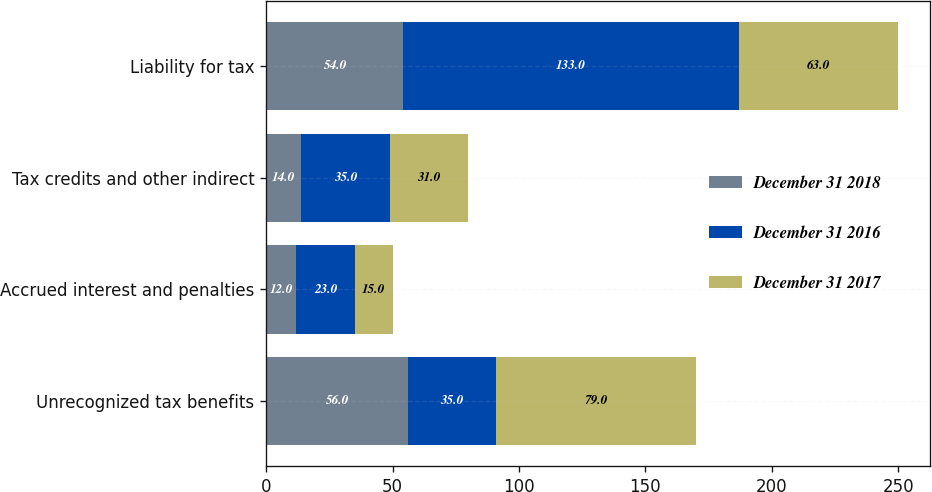Convert chart. <chart><loc_0><loc_0><loc_500><loc_500><stacked_bar_chart><ecel><fcel>Unrecognized tax benefits<fcel>Accrued interest and penalties<fcel>Tax credits and other indirect<fcel>Liability for tax<nl><fcel>December 31 2018<fcel>56<fcel>12<fcel>14<fcel>54<nl><fcel>December 31 2016<fcel>35<fcel>23<fcel>35<fcel>133<nl><fcel>December 31 2017<fcel>79<fcel>15<fcel>31<fcel>63<nl></chart> 